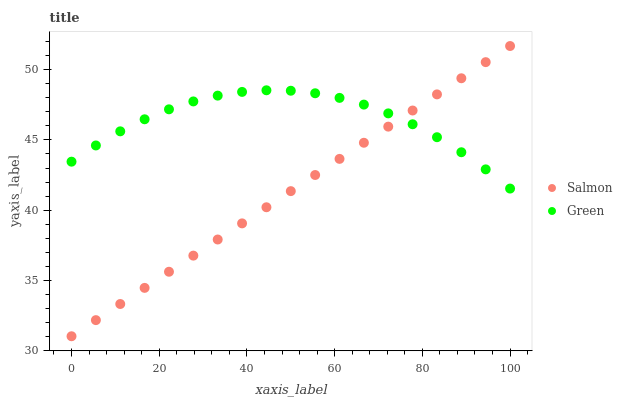Does Salmon have the minimum area under the curve?
Answer yes or no. Yes. Does Green have the maximum area under the curve?
Answer yes or no. Yes. Does Salmon have the maximum area under the curve?
Answer yes or no. No. Is Salmon the smoothest?
Answer yes or no. Yes. Is Green the roughest?
Answer yes or no. Yes. Is Salmon the roughest?
Answer yes or no. No. Does Salmon have the lowest value?
Answer yes or no. Yes. Does Salmon have the highest value?
Answer yes or no. Yes. Does Green intersect Salmon?
Answer yes or no. Yes. Is Green less than Salmon?
Answer yes or no. No. Is Green greater than Salmon?
Answer yes or no. No. 